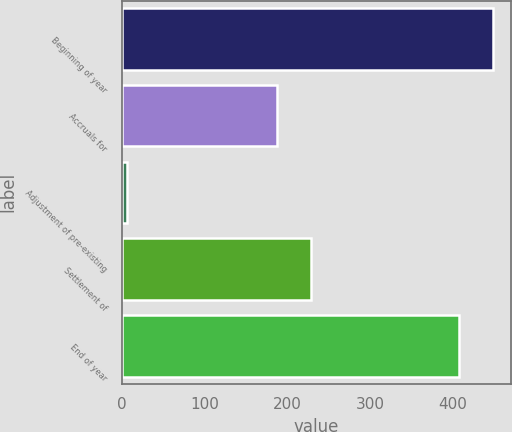Convert chart. <chart><loc_0><loc_0><loc_500><loc_500><bar_chart><fcel>Beginning of year<fcel>Accruals for<fcel>Adjustment of pre-existing<fcel>Settlement of<fcel>End of year<nl><fcel>448<fcel>188<fcel>7<fcel>229<fcel>407<nl></chart> 